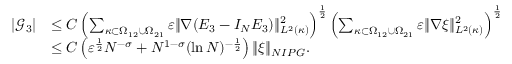Convert formula to latex. <formula><loc_0><loc_0><loc_500><loc_500>\begin{array} { r l } { | \mathcal { G } _ { 3 } | } & { \leq C \left ( \sum _ { \kappa \subset \Omega _ { 1 2 } \cup \Omega _ { 2 1 } } \varepsilon \| \nabla ( E _ { 3 } - I _ { N } E _ { 3 } ) \| _ { L ^ { 2 } ( \kappa ) } ^ { 2 } \right ) ^ { \frac { 1 } { 2 } } \left ( \sum _ { \kappa \subset \Omega _ { 1 2 } \cup \Omega _ { 2 1 } } \varepsilon \| \nabla \xi \| _ { L ^ { 2 } ( \kappa ) } ^ { 2 } \right ) ^ { \frac { 1 } { 2 } } } \\ & { \leq C \left ( \varepsilon ^ { \frac { 1 } { 2 } } N ^ { - \sigma } + N ^ { 1 - \sigma } ( \ln N ) ^ { - \frac { 1 } { 2 } } \right ) \| \xi \| _ { N I P G } . } \end{array}</formula> 